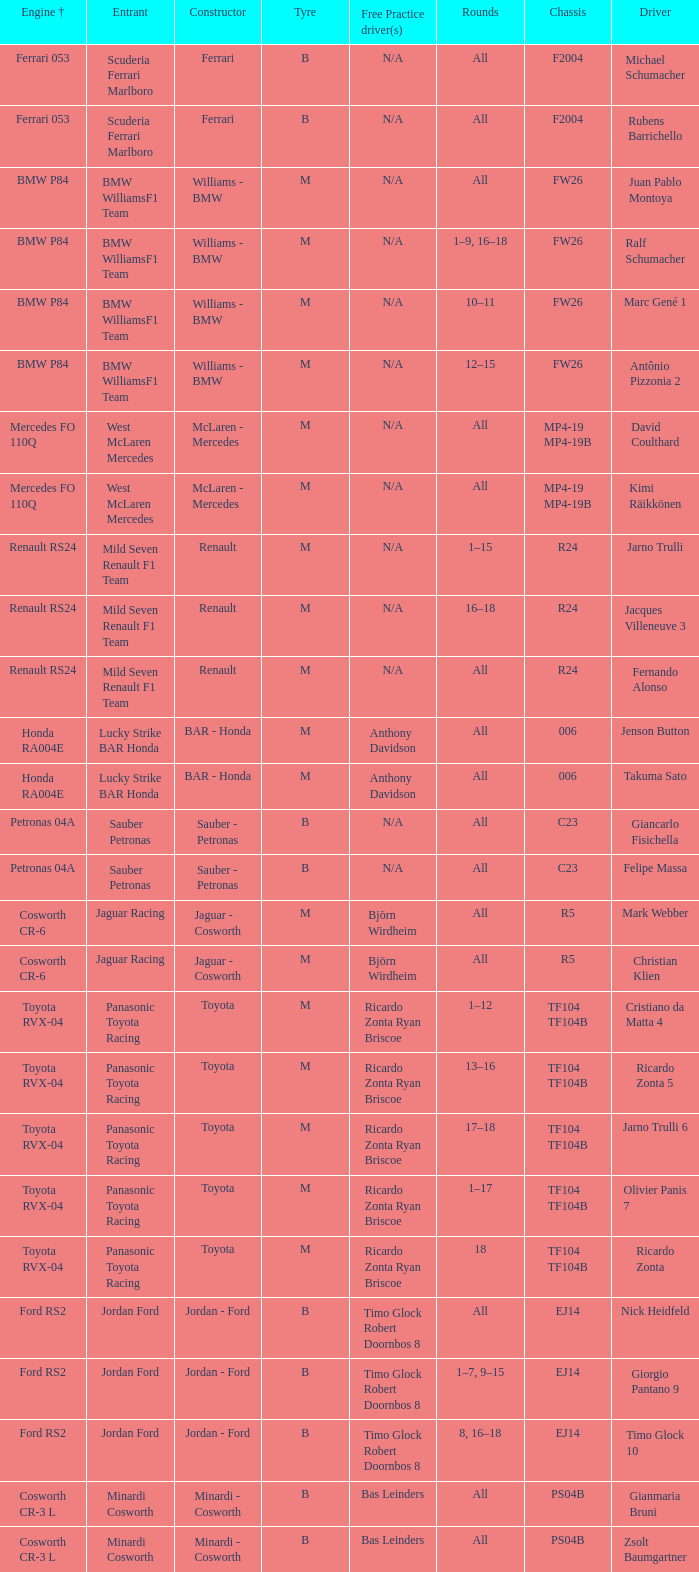What are the rounds for the B tyres and Ferrari 053 engine +? All, All. 